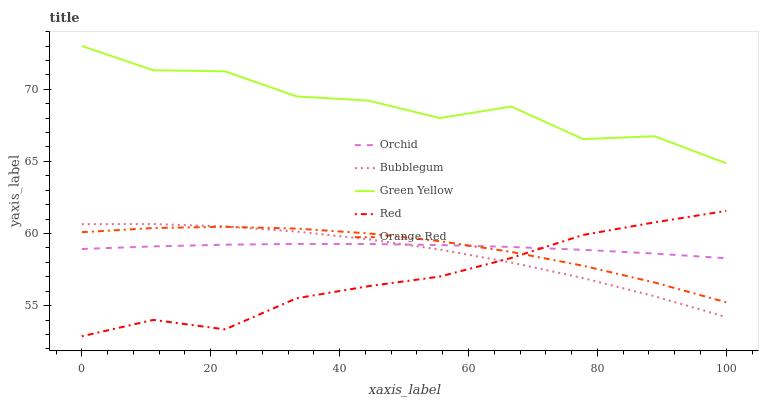Does Green Yellow have the minimum area under the curve?
Answer yes or no. No. Does Red have the maximum area under the curve?
Answer yes or no. No. Is Red the smoothest?
Answer yes or no. No. Is Red the roughest?
Answer yes or no. No. Does Green Yellow have the lowest value?
Answer yes or no. No. Does Red have the highest value?
Answer yes or no. No. Is Orange Red less than Green Yellow?
Answer yes or no. Yes. Is Green Yellow greater than Orchid?
Answer yes or no. Yes. Does Orange Red intersect Green Yellow?
Answer yes or no. No. 